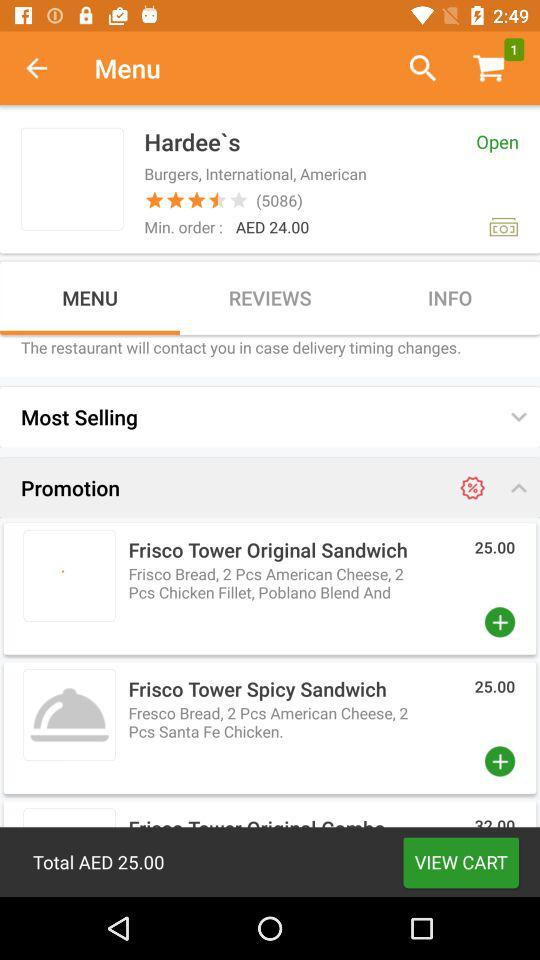What is the status of "Hardee's"? The status is "Open". 